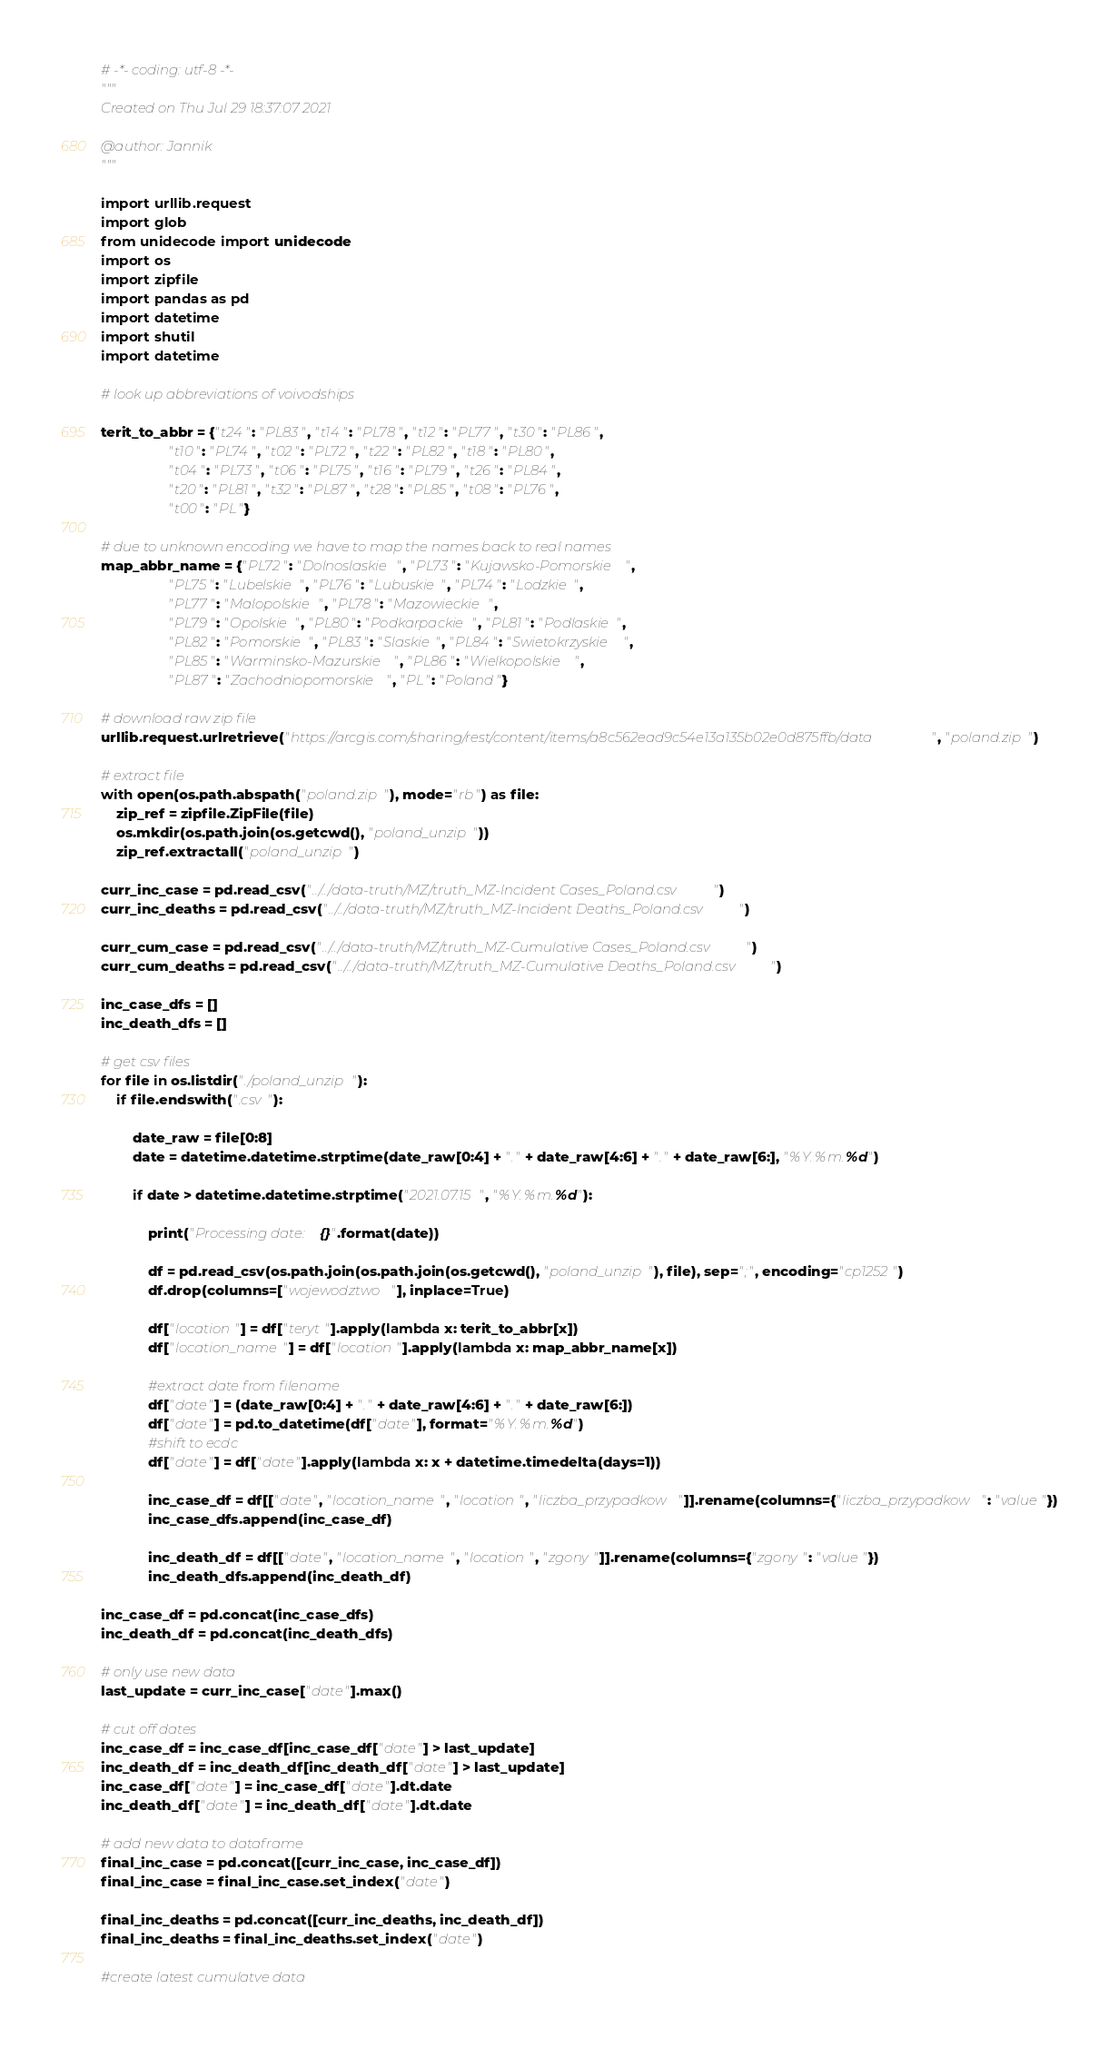<code> <loc_0><loc_0><loc_500><loc_500><_Python_># -*- coding: utf-8 -*-
"""
Created on Thu Jul 29 18:37:07 2021

@author: Jannik
"""

import urllib.request
import glob
from unidecode import unidecode
import os
import zipfile
import pandas as pd
import datetime
import shutil
import datetime
    
# look up abbreviations of voivodships

terit_to_abbr = {"t24": "PL83", "t14": "PL78", "t12": "PL77", "t30": "PL86", 
                 "t10": "PL74", "t02": "PL72", "t22": "PL82", "t18": "PL80",
                 "t04": "PL73", "t06": "PL75", "t16": "PL79", "t26": "PL84", 
                 "t20": "PL81", "t32": "PL87", "t28": "PL85", "t08": "PL76", 
                 "t00": "PL"}

# due to unknown encoding we have to map the names back to real names
map_abbr_name = {"PL72": "Dolnoslaskie", "PL73": "Kujawsko-Pomorskie",
                 "PL75": "Lubelskie", "PL76": "Lubuskie", "PL74": "Lodzkie",
                 "PL77": "Malopolskie", "PL78": "Mazowieckie",
                 "PL79": "Opolskie", "PL80": "Podkarpackie", "PL81": "Podlaskie",
                 "PL82": "Pomorskie", "PL83": "Slaskie", "PL84": "Swietokrzyskie",
                 "PL85": "Warminsko-Mazurskie", "PL86": "Wielkopolskie",
                 "PL87": "Zachodniopomorskie", "PL": "Poland"}

# download raw zip file
urllib.request.urlretrieve("https://arcgis.com/sharing/rest/content/items/a8c562ead9c54e13a135b02e0d875ffb/data", "poland.zip")

# extract file
with open(os.path.abspath("poland.zip"), mode="rb") as file:
    zip_ref = zipfile.ZipFile(file)
    os.mkdir(os.path.join(os.getcwd(), "poland_unzip"))
    zip_ref.extractall("poland_unzip")

curr_inc_case = pd.read_csv("../../data-truth/MZ/truth_MZ-Incident Cases_Poland.csv")
curr_inc_deaths = pd.read_csv("../../data-truth/MZ/truth_MZ-Incident Deaths_Poland.csv")

curr_cum_case = pd.read_csv("../../data-truth/MZ/truth_MZ-Cumulative Cases_Poland.csv")
curr_cum_deaths = pd.read_csv("../../data-truth/MZ/truth_MZ-Cumulative Deaths_Poland.csv")

inc_case_dfs = []
inc_death_dfs = []

# get csv files
for file in os.listdir("./poland_unzip"):
    if file.endswith(".csv"):
       
        date_raw = file[0:8]
        date = datetime.datetime.strptime(date_raw[0:4] + "." + date_raw[4:6] + "." + date_raw[6:], "%Y.%m.%d")
        
        if date > datetime.datetime.strptime("2021.07.15", "%Y.%m.%d"):
            
            print("Processing date: {}".format(date))
            
            df = pd.read_csv(os.path.join(os.path.join(os.getcwd(), "poland_unzip"), file), sep=";", encoding="cp1252")
            df.drop(columns=["wojewodztwo"], inplace=True)
                
            df["location"] = df["teryt"].apply(lambda x: terit_to_abbr[x])
            df["location_name"] = df["location"].apply(lambda x: map_abbr_name[x])
            
            #extract date from filename
            df["date"] = (date_raw[0:4] + "." + date_raw[4:6] + "." + date_raw[6:])
            df["date"] = pd.to_datetime(df["date"], format="%Y.%m.%d")
            #shift to ecdc
            df["date"] = df["date"].apply(lambda x: x + datetime.timedelta(days=1))
            
            inc_case_df = df[["date", "location_name", "location", "liczba_przypadkow"]].rename(columns={"liczba_przypadkow": "value"})
            inc_case_dfs.append(inc_case_df)
            
            inc_death_df = df[["date", "location_name", "location", "zgony"]].rename(columns={"zgony": "value"})
            inc_death_dfs.append(inc_death_df)

inc_case_df = pd.concat(inc_case_dfs)
inc_death_df = pd.concat(inc_death_dfs)

# only use new data
last_update = curr_inc_case["date"].max()

# cut off dates
inc_case_df = inc_case_df[inc_case_df["date"] > last_update]
inc_death_df = inc_death_df[inc_death_df["date"] > last_update]
inc_case_df["date"] = inc_case_df["date"].dt.date
inc_death_df["date"] = inc_death_df["date"].dt.date

# add new data to dataframe
final_inc_case = pd.concat([curr_inc_case, inc_case_df])
final_inc_case = final_inc_case.set_index("date")

final_inc_deaths = pd.concat([curr_inc_deaths, inc_death_df])
final_inc_deaths = final_inc_deaths.set_index("date")

#create latest cumulatve data</code> 